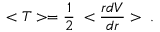Convert formula to latex. <formula><loc_0><loc_0><loc_500><loc_500>< T > = \frac { 1 } { 2 } \, < \frac { r d V } { d r } > \, .</formula> 